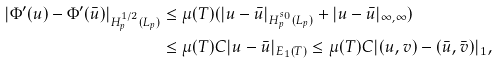<formula> <loc_0><loc_0><loc_500><loc_500>| \Phi ^ { \prime } ( u ) - \Phi ^ { \prime } ( \bar { u } ) | _ { H _ { p } ^ { 1 / 2 } ( L _ { p } ) } & \leq \mu ( T ) ( | u - \bar { u } | _ { H _ { p } ^ { s _ { 0 } } ( L _ { p } ) } + | u - \bar { u } | _ { \infty , \infty } ) \\ & \leq \mu ( T ) C | u - \bar { u } | _ { E _ { 1 } ( T ) } \leq \mu ( T ) C | ( u , v ) - ( \bar { u } , \bar { v } ) | _ { 1 } ,</formula> 